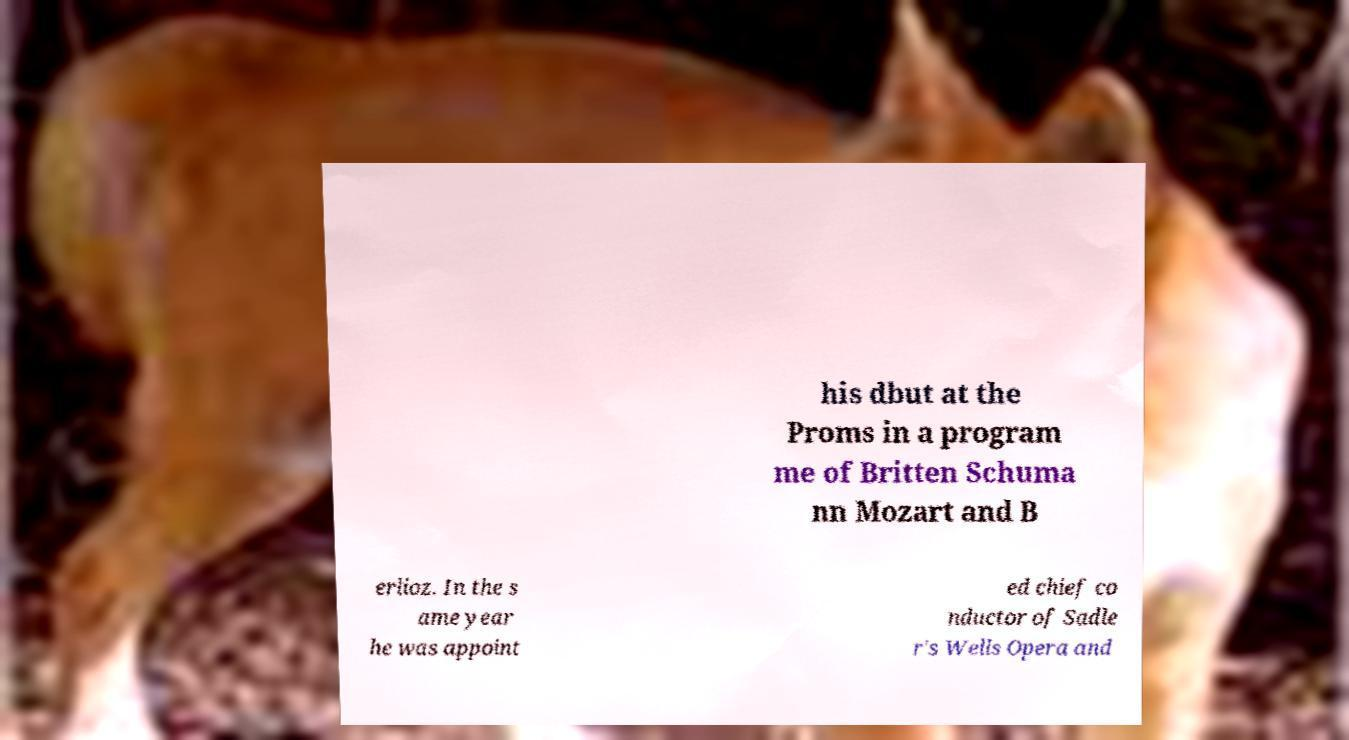Can you read and provide the text displayed in the image?This photo seems to have some interesting text. Can you extract and type it out for me? his dbut at the Proms in a program me of Britten Schuma nn Mozart and B erlioz. In the s ame year he was appoint ed chief co nductor of Sadle r's Wells Opera and 